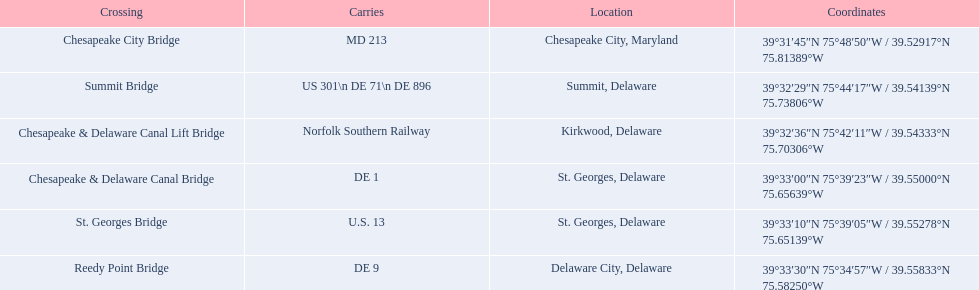What are the carriers of the crossing situated in summit, delaware? US 301\n DE 71\n DE 896. Based on the response in the prior question, what is the title of the crossing? Summit Bridge. 